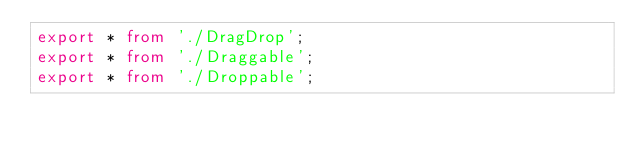Convert code to text. <code><loc_0><loc_0><loc_500><loc_500><_TypeScript_>export * from './DragDrop';
export * from './Draggable';
export * from './Droppable';
</code> 